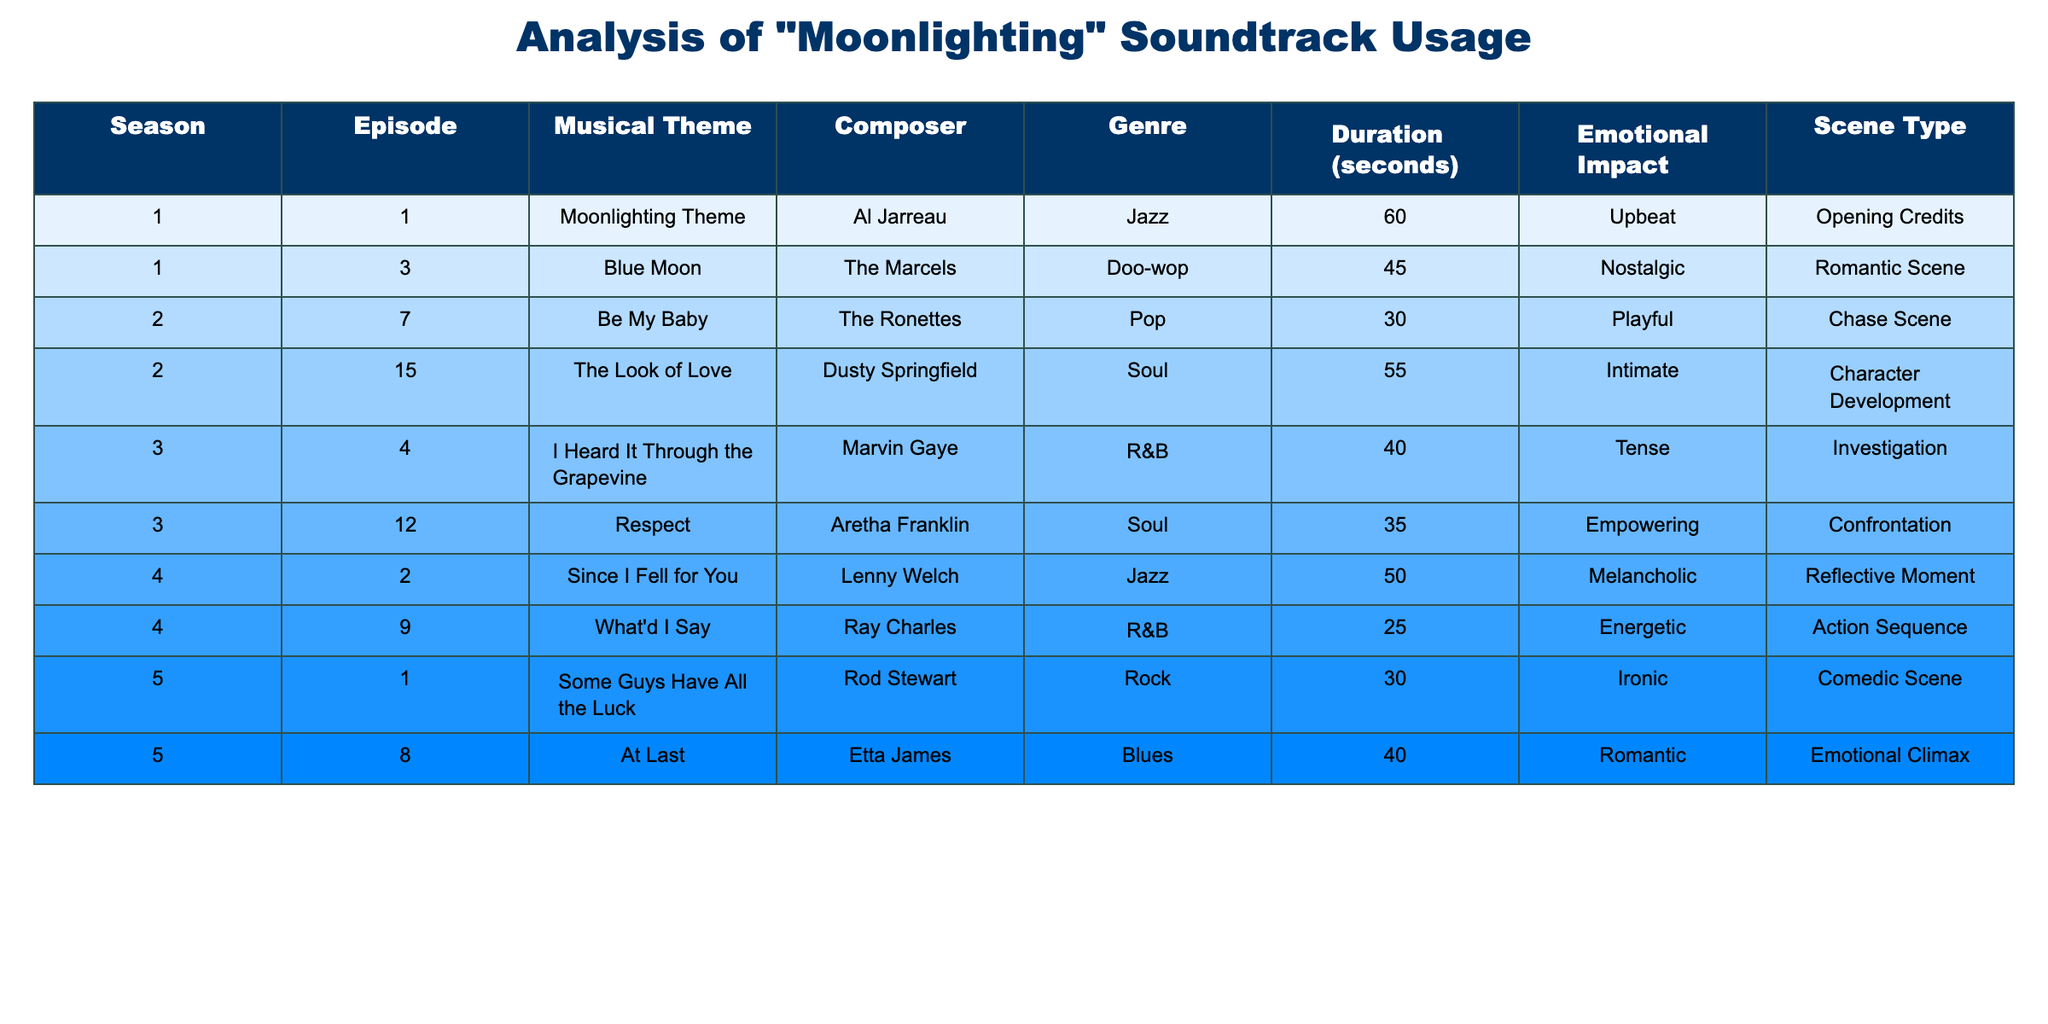What is the musical theme used in Season 3, Episode 4? According to the table, the musical theme for Season 3, Episode 4 is "I Heard It Through the Grapevine".
Answer: I Heard It Through the Grapevine Which composer created the soundtrack for the opening credits? The table shows that Al Jarreau composed the "Moonlighting Theme," which is used for the opening credits in Season 1, Episode 1.
Answer: Al Jarreau How many seconds does the "Be My Baby" track last? From the table, "Be My Baby" lasts 30 seconds as indicated in the Duration column for Season 2, Episode 7.
Answer: 30 seconds What is the emotional impact of the soundtrack used in the romantic scene from Season 1, Episode 3? The table indicates that the emotional impact of "Blue Moon" in this episode is "Nostalgic" based on its classification in the Emotional Impact column.
Answer: Nostalgic Which genre has the longest duration soundtracks in the table? By examining the table for each genre, Jazz has a total duration of 60 seconds for "Moonlighting Theme" and 50 seconds for "Since I Fell for You," totaling 110 seconds, more than any other genre.
Answer: Jazz Is there a soundtrack with an "Empowering" emotional impact? Yes, according to the table, "Respect" by Aretha Franklin is marked with an "Empowering" emotional impact for Season 3, Episode 12.
Answer: Yes Which season features the most soundtrack entries in the table? To find out, count the number of entries for each season in the table: Season 1 has 2, Season 2 has 2, Season 3 has 2, Season 4 has 2, and Season 5 has 2. Each season has the same number of entries (2).
Answer: None - all seasons have the same number of entries What is the total duration of soundtracks in Season 2? By adding the durations for soundtracks in Season 2: "Be My Baby" (30 seconds) and "The Look of Love" (55 seconds), the total is 85 seconds.
Answer: 85 seconds Which episode contains a soundtrack with a melancholic emotional impact? The table indicates that "Since I Fell for You" in Season 4, Episode 2 has a melancholic emotional impact.
Answer: Season 4, Episode 2 Which episode features a chase scene and what is the corresponding musical theme? The table shows that in Season 2, Episode 7, the chase scene features the musical theme "Be My Baby".
Answer: Season 2, Episode 7 - Be My Baby 